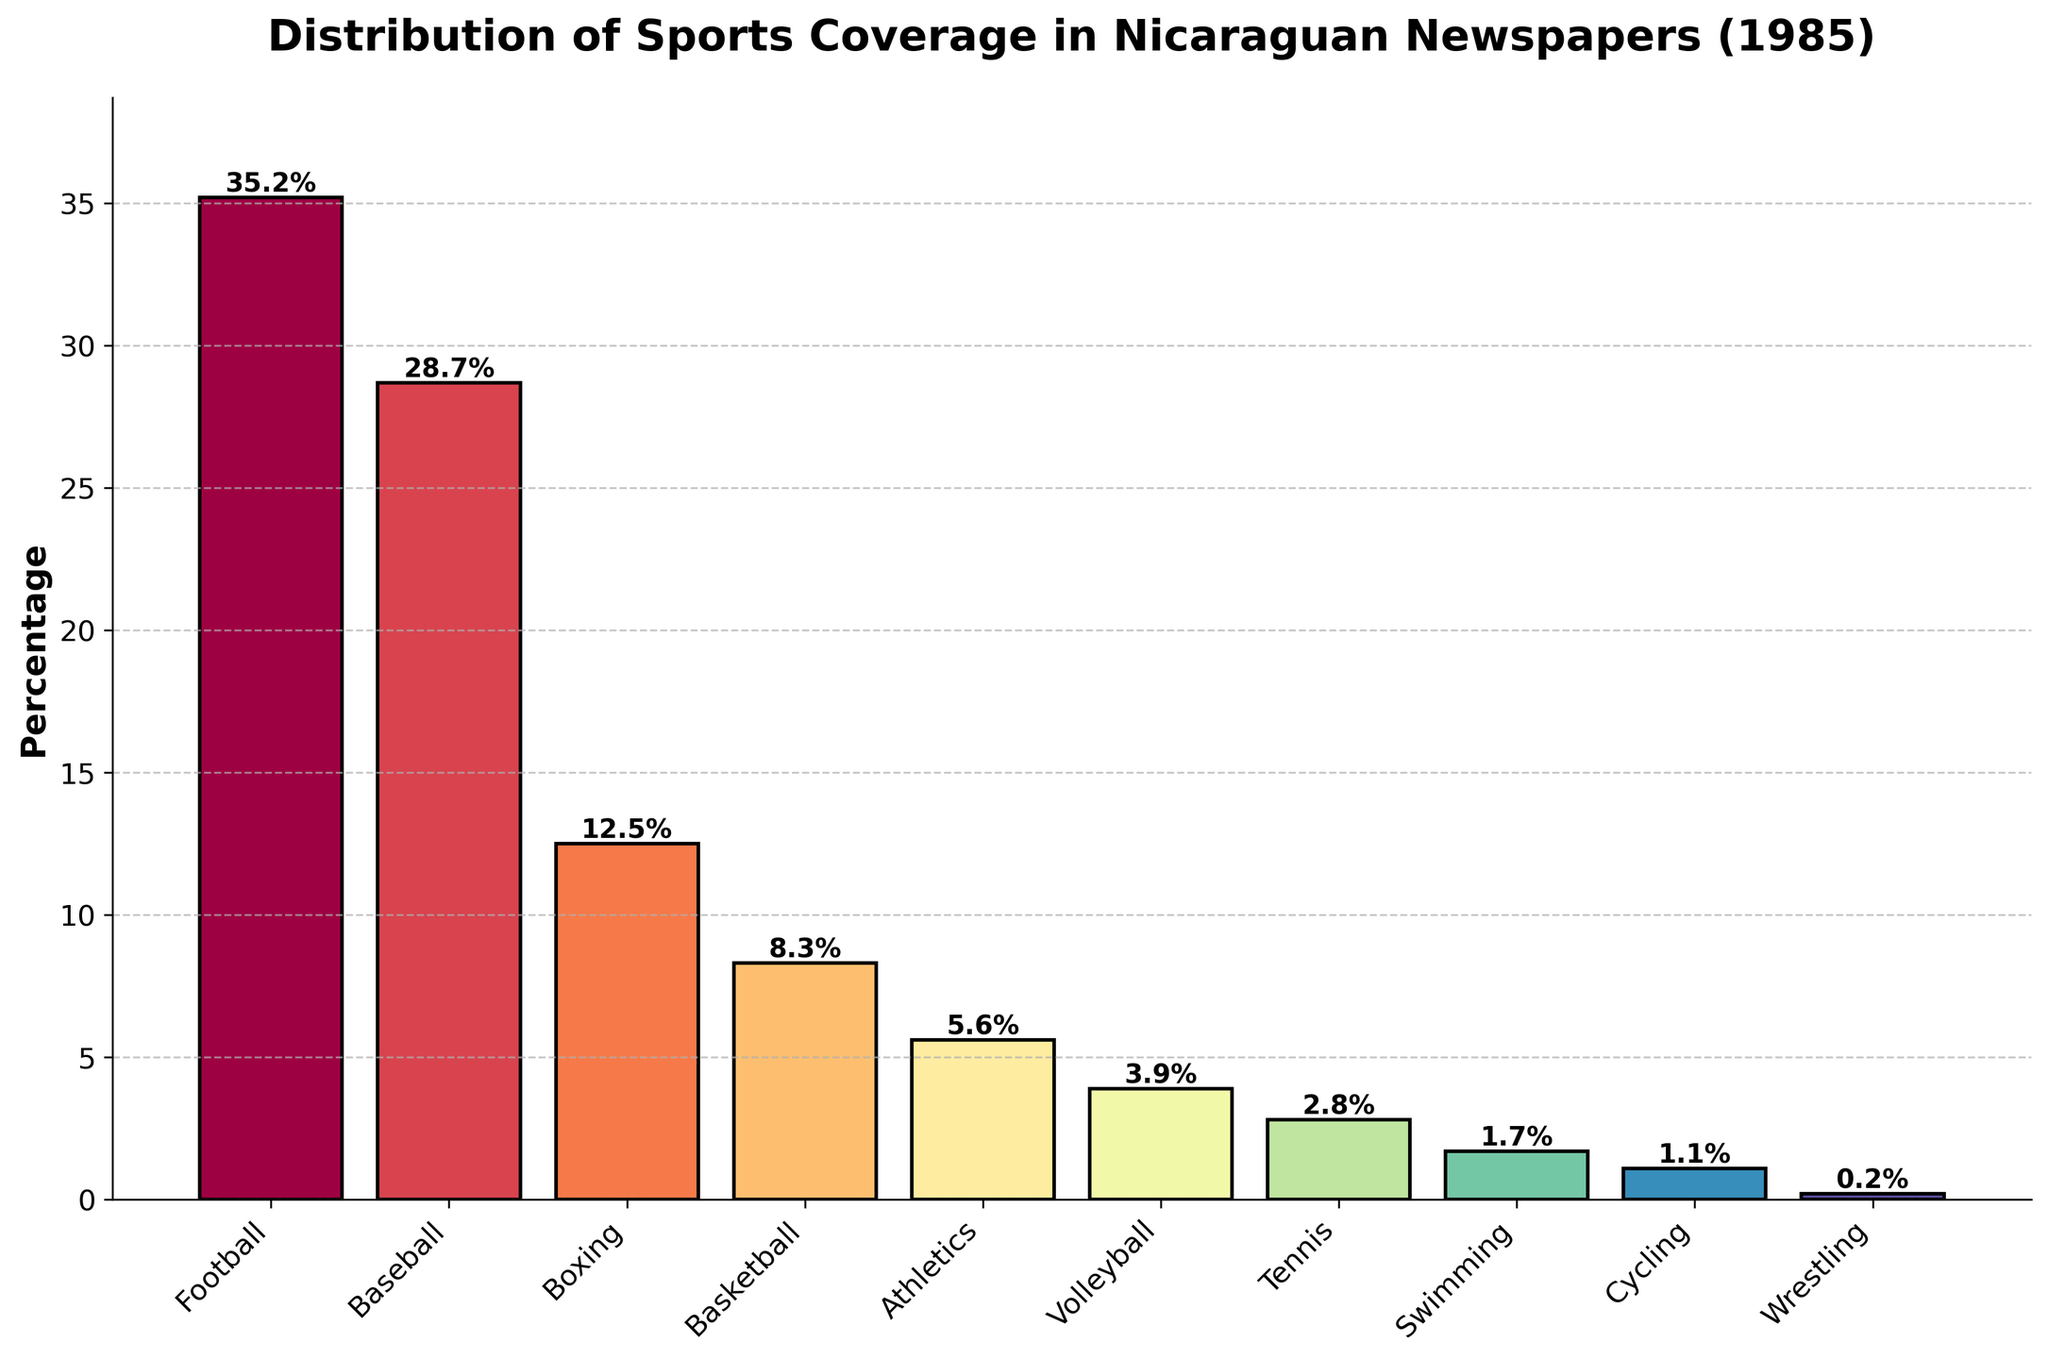Which sport had the highest coverage in Nicaraguan newspapers in 1985? To identify the sport with the highest coverage, observe the bar with the greatest height. In this figure, the highest bar is for Football.
Answer: Football Which two sports combined made up more than half of the coverage in Nicaraguan newspapers in 1985? Add the percentages of the top two sports. Football has 35.2% and Baseball has 28.7%. Their combined coverage is 35.2% + 28.7% = 63.9%, which is more than half.
Answer: Football and Baseball How much more coverage did Football receive compared to Boxing? Subtract Boxing's percentage from Football's. Football has 35.2% and Boxing has 12.5%. The difference is 35.2% - 12.5% = 22.7%.
Answer: 22.7% What is the combined percentage of coverage for sports with less than 5% individual coverage? Sum the percentages of Volleyball (3.9%), Tennis (2.8%), Swimming (1.7%), Cycling (1.1%), and Wrestling (0.2%). The total is 3.9% + 2.8% + 1.7% + 1.1% + 0.2% = 9.7%.
Answer: 9.7% Which sport had roughly half the coverage of Basketball? Basketball has 8.3%. Find the sport with about half that value. Volleyball at 3.9% is closest to half of 8.3%.
Answer: Volleyball Arrange the sports in ascending order of their coverage percentages. Arrange the sports from the smallest to largest percentage: Wrestling (0.2%), Cycling (1.1%), Swimming (1.7%), Tennis (2.8%), Volleyball (3.9%), Athletics (5.6%), Basketball (8.3%), Boxing (12.5%), Baseball (28.7%), Football (35.2%).
Answer: Wrestling, Cycling, Swimming, Tennis, Volleyball, Athletics, Basketball, Boxing, Baseball, Football What is the difference in coverage percentage between the sport with the least coverage and the sport with the third least coverage? Identify the percentages for Wrestling (0.2%) and Swimming (1.7%). The difference is 1.7% - 0.2% = 1.5%.
Answer: 1.5% How many sports have a coverage percentage above the median value? The median value of the sorted percentages is between Athletics (5.6%) and Basketball (8.3%) making it 7%. Identify sports above 7%: Football (35.2%), Baseball (28.7%), Boxing (12.5%), Basketball (8.3%). Count them.
Answer: 4 What fraction of the total coverage does Football represent? Calculate Football's coverage as a fraction of the total of all percentages. Sum all percentages: 35.2% + 28.7% + 12.5% + 8.3% + 5.6% + 3.9% + 2.8% + 1.7% + 1.1% + 0.2% = 100%. Football has 35.2% of 100%.
Answer: 35.2% 